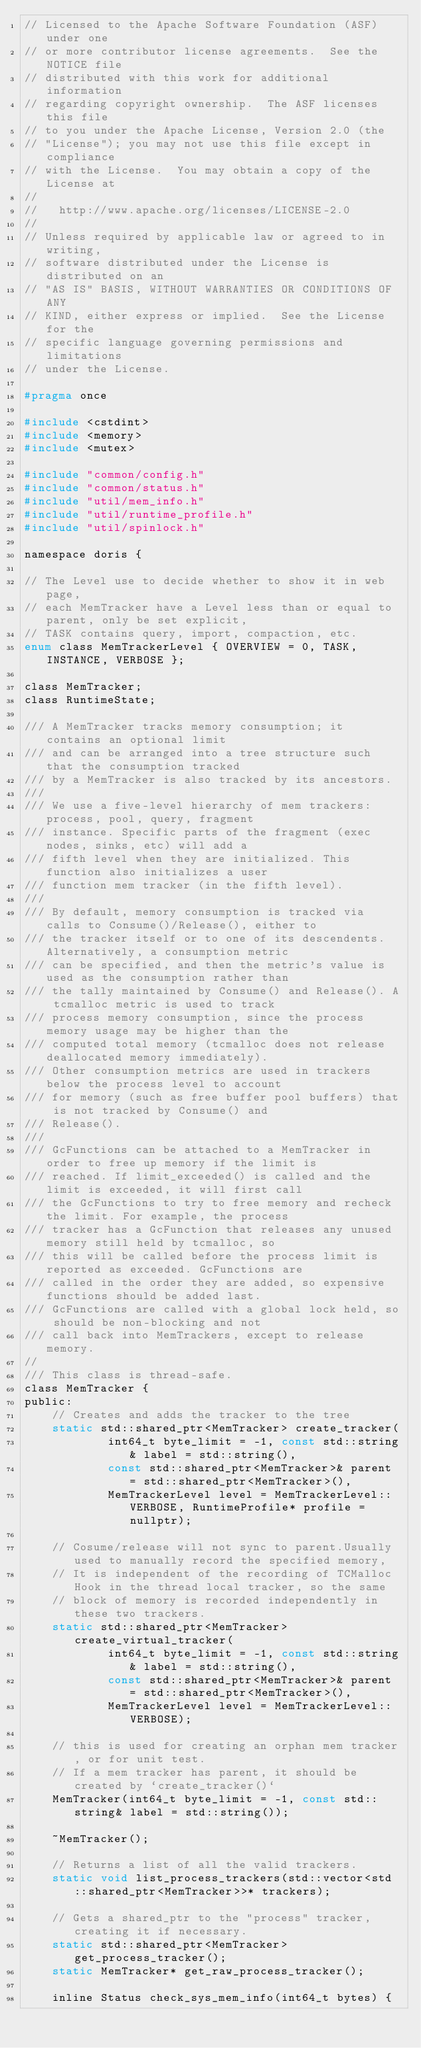<code> <loc_0><loc_0><loc_500><loc_500><_C_>// Licensed to the Apache Software Foundation (ASF) under one
// or more contributor license agreements.  See the NOTICE file
// distributed with this work for additional information
// regarding copyright ownership.  The ASF licenses this file
// to you under the Apache License, Version 2.0 (the
// "License"); you may not use this file except in compliance
// with the License.  You may obtain a copy of the License at
//
//   http://www.apache.org/licenses/LICENSE-2.0
//
// Unless required by applicable law or agreed to in writing,
// software distributed under the License is distributed on an
// "AS IS" BASIS, WITHOUT WARRANTIES OR CONDITIONS OF ANY
// KIND, either express or implied.  See the License for the
// specific language governing permissions and limitations
// under the License.

#pragma once

#include <cstdint>
#include <memory>
#include <mutex>

#include "common/config.h"
#include "common/status.h"
#include "util/mem_info.h"
#include "util/runtime_profile.h"
#include "util/spinlock.h"

namespace doris {

// The Level use to decide whether to show it in web page,
// each MemTracker have a Level less than or equal to parent, only be set explicit,
// TASK contains query, import, compaction, etc.
enum class MemTrackerLevel { OVERVIEW = 0, TASK, INSTANCE, VERBOSE };

class MemTracker;
class RuntimeState;

/// A MemTracker tracks memory consumption; it contains an optional limit
/// and can be arranged into a tree structure such that the consumption tracked
/// by a MemTracker is also tracked by its ancestors.
///
/// We use a five-level hierarchy of mem trackers: process, pool, query, fragment
/// instance. Specific parts of the fragment (exec nodes, sinks, etc) will add a
/// fifth level when they are initialized. This function also initializes a user
/// function mem tracker (in the fifth level).
///
/// By default, memory consumption is tracked via calls to Consume()/Release(), either to
/// the tracker itself or to one of its descendents. Alternatively, a consumption metric
/// can be specified, and then the metric's value is used as the consumption rather than
/// the tally maintained by Consume() and Release(). A tcmalloc metric is used to track
/// process memory consumption, since the process memory usage may be higher than the
/// computed total memory (tcmalloc does not release deallocated memory immediately).
/// Other consumption metrics are used in trackers below the process level to account
/// for memory (such as free buffer pool buffers) that is not tracked by Consume() and
/// Release().
///
/// GcFunctions can be attached to a MemTracker in order to free up memory if the limit is
/// reached. If limit_exceeded() is called and the limit is exceeded, it will first call
/// the GcFunctions to try to free memory and recheck the limit. For example, the process
/// tracker has a GcFunction that releases any unused memory still held by tcmalloc, so
/// this will be called before the process limit is reported as exceeded. GcFunctions are
/// called in the order they are added, so expensive functions should be added last.
/// GcFunctions are called with a global lock held, so should be non-blocking and not
/// call back into MemTrackers, except to release memory.
//
/// This class is thread-safe.
class MemTracker {
public:
    // Creates and adds the tracker to the tree
    static std::shared_ptr<MemTracker> create_tracker(
            int64_t byte_limit = -1, const std::string& label = std::string(),
            const std::shared_ptr<MemTracker>& parent = std::shared_ptr<MemTracker>(),
            MemTrackerLevel level = MemTrackerLevel::VERBOSE, RuntimeProfile* profile = nullptr);

    // Cosume/release will not sync to parent.Usually used to manually record the specified memory,
    // It is independent of the recording of TCMalloc Hook in the thread local tracker, so the same
    // block of memory is recorded independently in these two trackers.
    static std::shared_ptr<MemTracker> create_virtual_tracker(
            int64_t byte_limit = -1, const std::string& label = std::string(),
            const std::shared_ptr<MemTracker>& parent = std::shared_ptr<MemTracker>(),
            MemTrackerLevel level = MemTrackerLevel::VERBOSE);

    // this is used for creating an orphan mem tracker, or for unit test.
    // If a mem tracker has parent, it should be created by `create_tracker()`
    MemTracker(int64_t byte_limit = -1, const std::string& label = std::string());

    ~MemTracker();

    // Returns a list of all the valid trackers.
    static void list_process_trackers(std::vector<std::shared_ptr<MemTracker>>* trackers);

    // Gets a shared_ptr to the "process" tracker, creating it if necessary.
    static std::shared_ptr<MemTracker> get_process_tracker();
    static MemTracker* get_raw_process_tracker();

    inline Status check_sys_mem_info(int64_t bytes) {</code> 